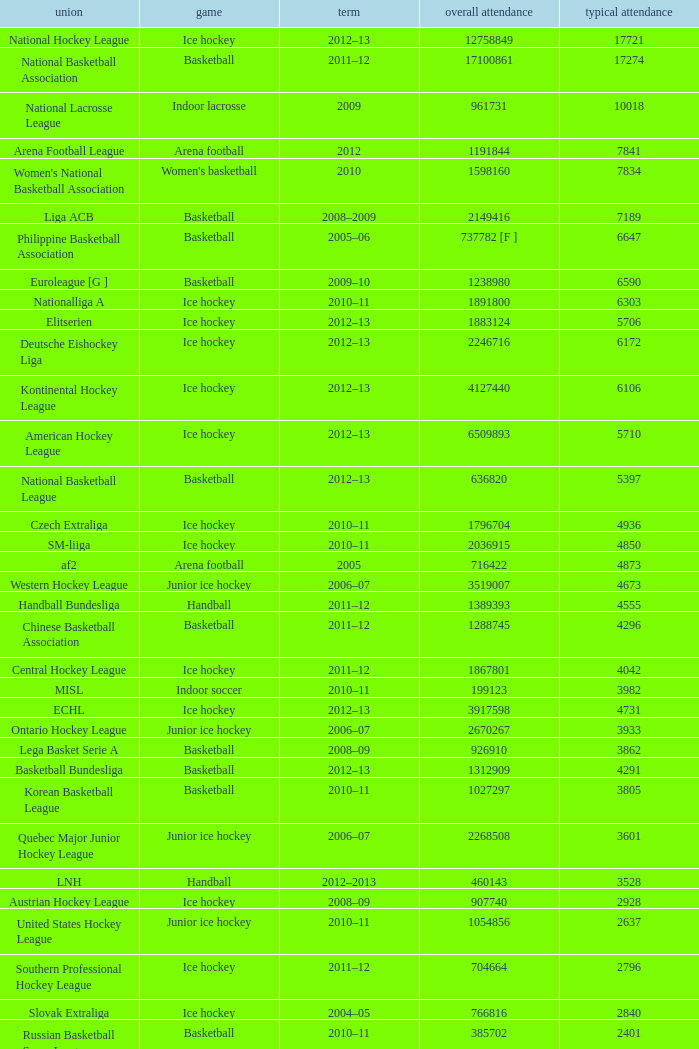What's the total attendance in rink hockey when the average attendance was smaller than 4850? 115000.0. 